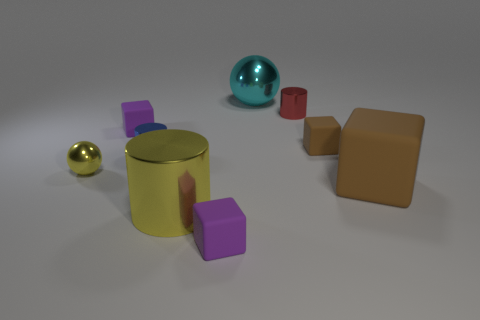Subtract all red cylinders. How many cylinders are left? 2 Add 1 small gray shiny spheres. How many objects exist? 10 Subtract all red cylinders. How many brown blocks are left? 2 Subtract all balls. How many objects are left? 7 Subtract 1 spheres. How many spheres are left? 1 Add 4 small red objects. How many small red objects exist? 5 Subtract all yellow spheres. How many spheres are left? 1 Subtract 0 brown balls. How many objects are left? 9 Subtract all cyan balls. Subtract all gray blocks. How many balls are left? 1 Subtract all small yellow metal things. Subtract all blocks. How many objects are left? 4 